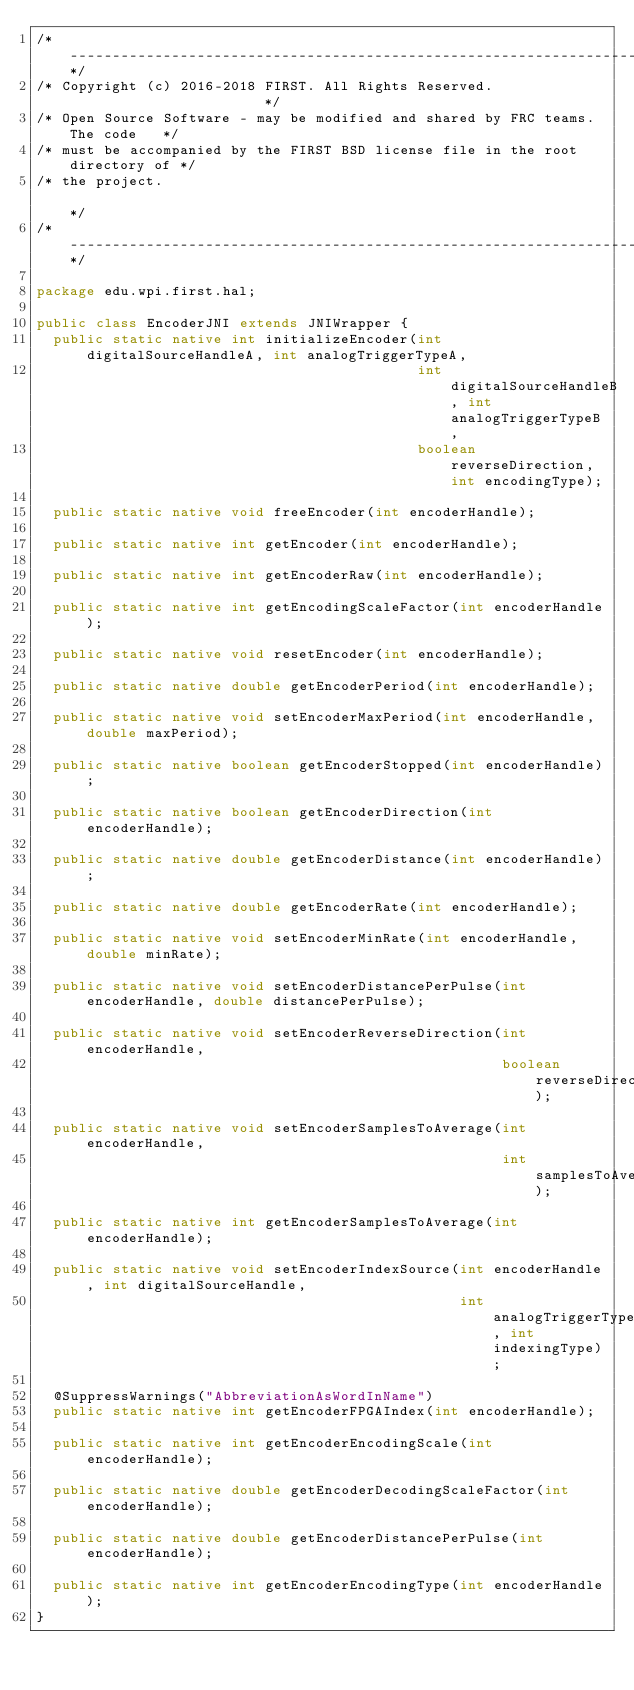<code> <loc_0><loc_0><loc_500><loc_500><_Java_>/*----------------------------------------------------------------------------*/
/* Copyright (c) 2016-2018 FIRST. All Rights Reserved.                        */
/* Open Source Software - may be modified and shared by FRC teams. The code   */
/* must be accompanied by the FIRST BSD license file in the root directory of */
/* the project.                                                               */
/*----------------------------------------------------------------------------*/

package edu.wpi.first.hal;

public class EncoderJNI extends JNIWrapper {
  public static native int initializeEncoder(int digitalSourceHandleA, int analogTriggerTypeA,
                                             int digitalSourceHandleB, int analogTriggerTypeB,
                                             boolean reverseDirection, int encodingType);

  public static native void freeEncoder(int encoderHandle);

  public static native int getEncoder(int encoderHandle);

  public static native int getEncoderRaw(int encoderHandle);

  public static native int getEncodingScaleFactor(int encoderHandle);

  public static native void resetEncoder(int encoderHandle);

  public static native double getEncoderPeriod(int encoderHandle);

  public static native void setEncoderMaxPeriod(int encoderHandle, double maxPeriod);

  public static native boolean getEncoderStopped(int encoderHandle);

  public static native boolean getEncoderDirection(int encoderHandle);

  public static native double getEncoderDistance(int encoderHandle);

  public static native double getEncoderRate(int encoderHandle);

  public static native void setEncoderMinRate(int encoderHandle, double minRate);

  public static native void setEncoderDistancePerPulse(int encoderHandle, double distancePerPulse);

  public static native void setEncoderReverseDirection(int encoderHandle,
                                                       boolean reverseDirection);

  public static native void setEncoderSamplesToAverage(int encoderHandle,
                                                       int samplesToAverage);

  public static native int getEncoderSamplesToAverage(int encoderHandle);

  public static native void setEncoderIndexSource(int encoderHandle, int digitalSourceHandle,
                                                  int analogTriggerType, int indexingType);

  @SuppressWarnings("AbbreviationAsWordInName")
  public static native int getEncoderFPGAIndex(int encoderHandle);

  public static native int getEncoderEncodingScale(int encoderHandle);

  public static native double getEncoderDecodingScaleFactor(int encoderHandle);

  public static native double getEncoderDistancePerPulse(int encoderHandle);

  public static native int getEncoderEncodingType(int encoderHandle);
}
</code> 